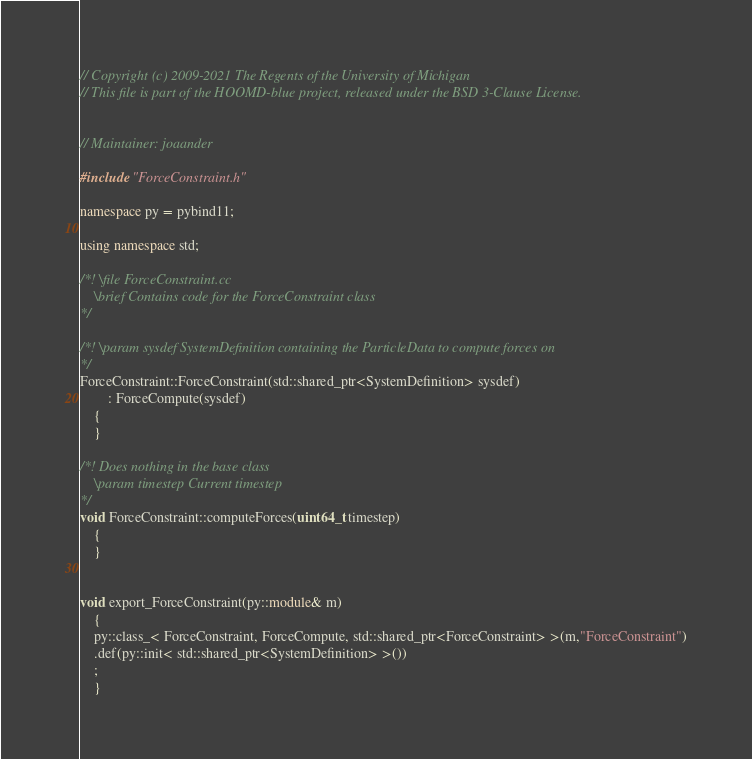Convert code to text. <code><loc_0><loc_0><loc_500><loc_500><_C++_>// Copyright (c) 2009-2021 The Regents of the University of Michigan
// This file is part of the HOOMD-blue project, released under the BSD 3-Clause License.


// Maintainer: joaander

#include "ForceConstraint.h"

namespace py = pybind11;

using namespace std;

/*! \file ForceConstraint.cc
    \brief Contains code for the ForceConstraint class
*/

/*! \param sysdef SystemDefinition containing the ParticleData to compute forces on
*/
ForceConstraint::ForceConstraint(std::shared_ptr<SystemDefinition> sysdef)
        : ForceCompute(sysdef)
    {
    }

/*! Does nothing in the base class
    \param timestep Current timestep
*/
void ForceConstraint::computeForces(uint64_t timestep)
    {
    }


void export_ForceConstraint(py::module& m)
    {
    py::class_< ForceConstraint, ForceCompute, std::shared_ptr<ForceConstraint> >(m,"ForceConstraint")
    .def(py::init< std::shared_ptr<SystemDefinition> >())
    ;
    }
</code> 